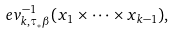<formula> <loc_0><loc_0><loc_500><loc_500>e v _ { k , \tau _ { * } \beta } ^ { - 1 } ( x _ { 1 } \times \cdots \times x _ { k - 1 } ) ,</formula> 